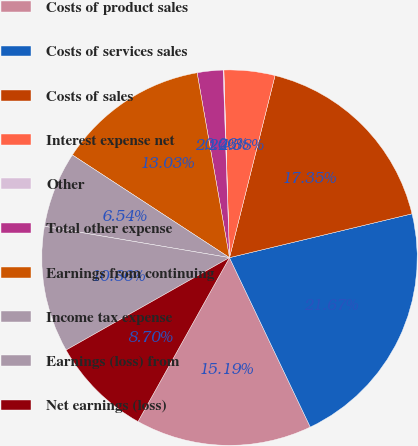<chart> <loc_0><loc_0><loc_500><loc_500><pie_chart><fcel>Costs of product sales<fcel>Costs of services sales<fcel>Costs of sales<fcel>Interest expense net<fcel>Other<fcel>Total other expense<fcel>Earnings from continuing<fcel>Income tax expense<fcel>Earnings (loss) from<fcel>Net earnings (loss)<nl><fcel>15.18%<fcel>21.66%<fcel>17.34%<fcel>4.38%<fcel>0.06%<fcel>2.22%<fcel>13.02%<fcel>6.54%<fcel>10.86%<fcel>8.7%<nl></chart> 